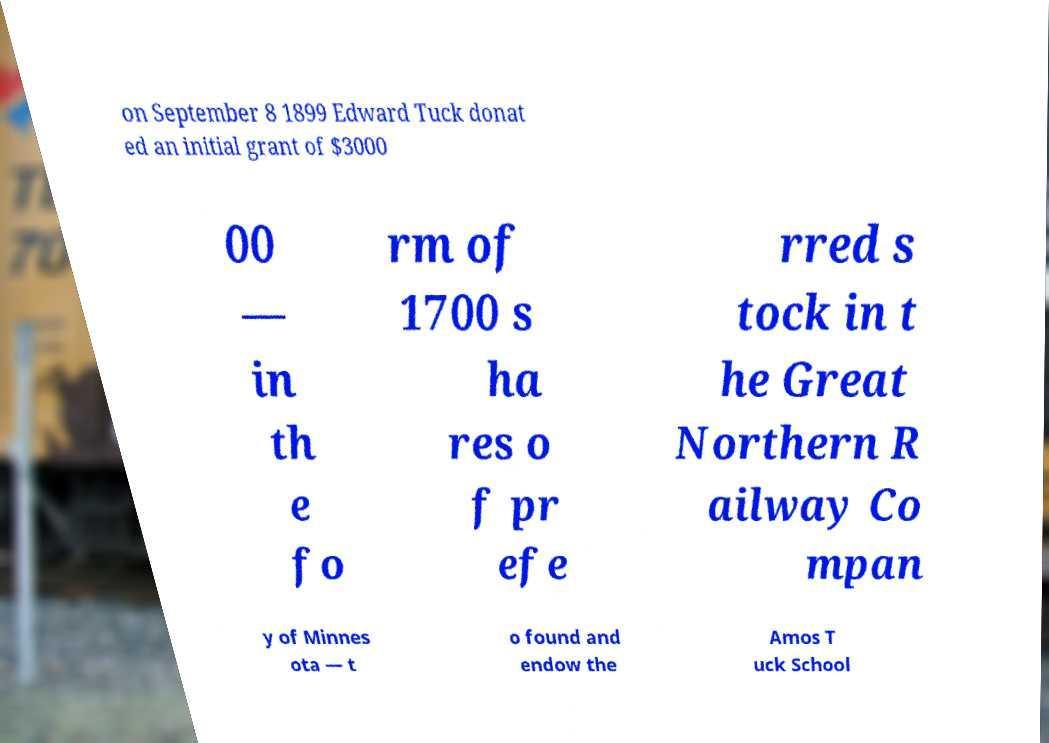Could you extract and type out the text from this image? on September 8 1899 Edward Tuck donat ed an initial grant of $3000 00 — in th e fo rm of 1700 s ha res o f pr efe rred s tock in t he Great Northern R ailway Co mpan y of Minnes ota — t o found and endow the Amos T uck School 